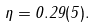<formula> <loc_0><loc_0><loc_500><loc_500>\eta = 0 . 2 9 ( 5 ) .</formula> 